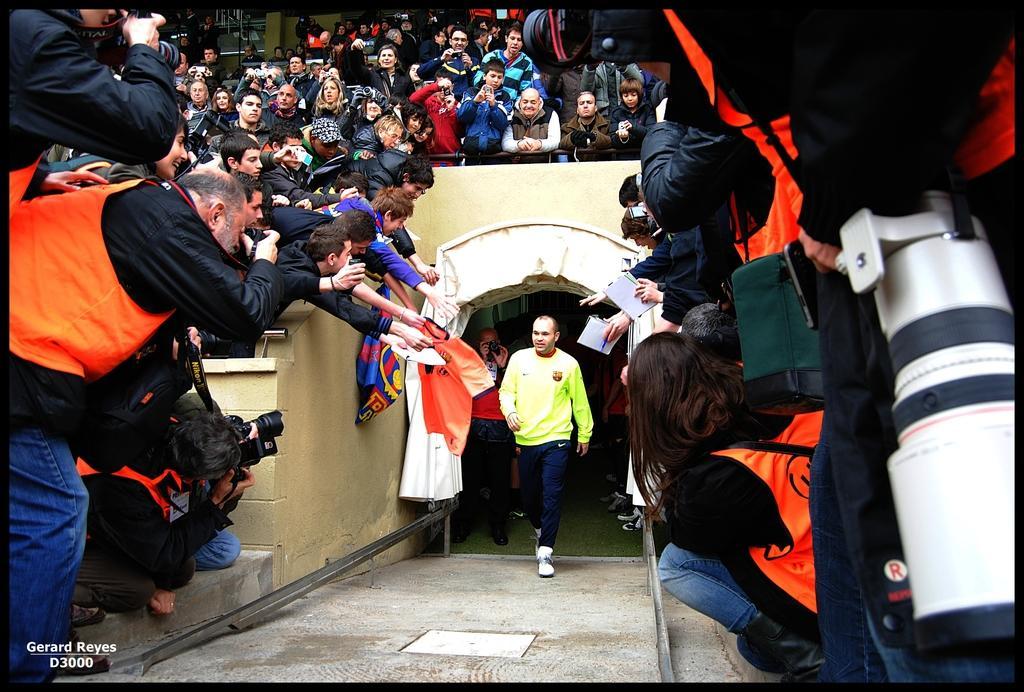Please provide a concise description of this image. In this image I can see a person walking wearing green shirt, blue pant. Background I can see group of people some are standing and some are sitting and I can also see few cameras. 